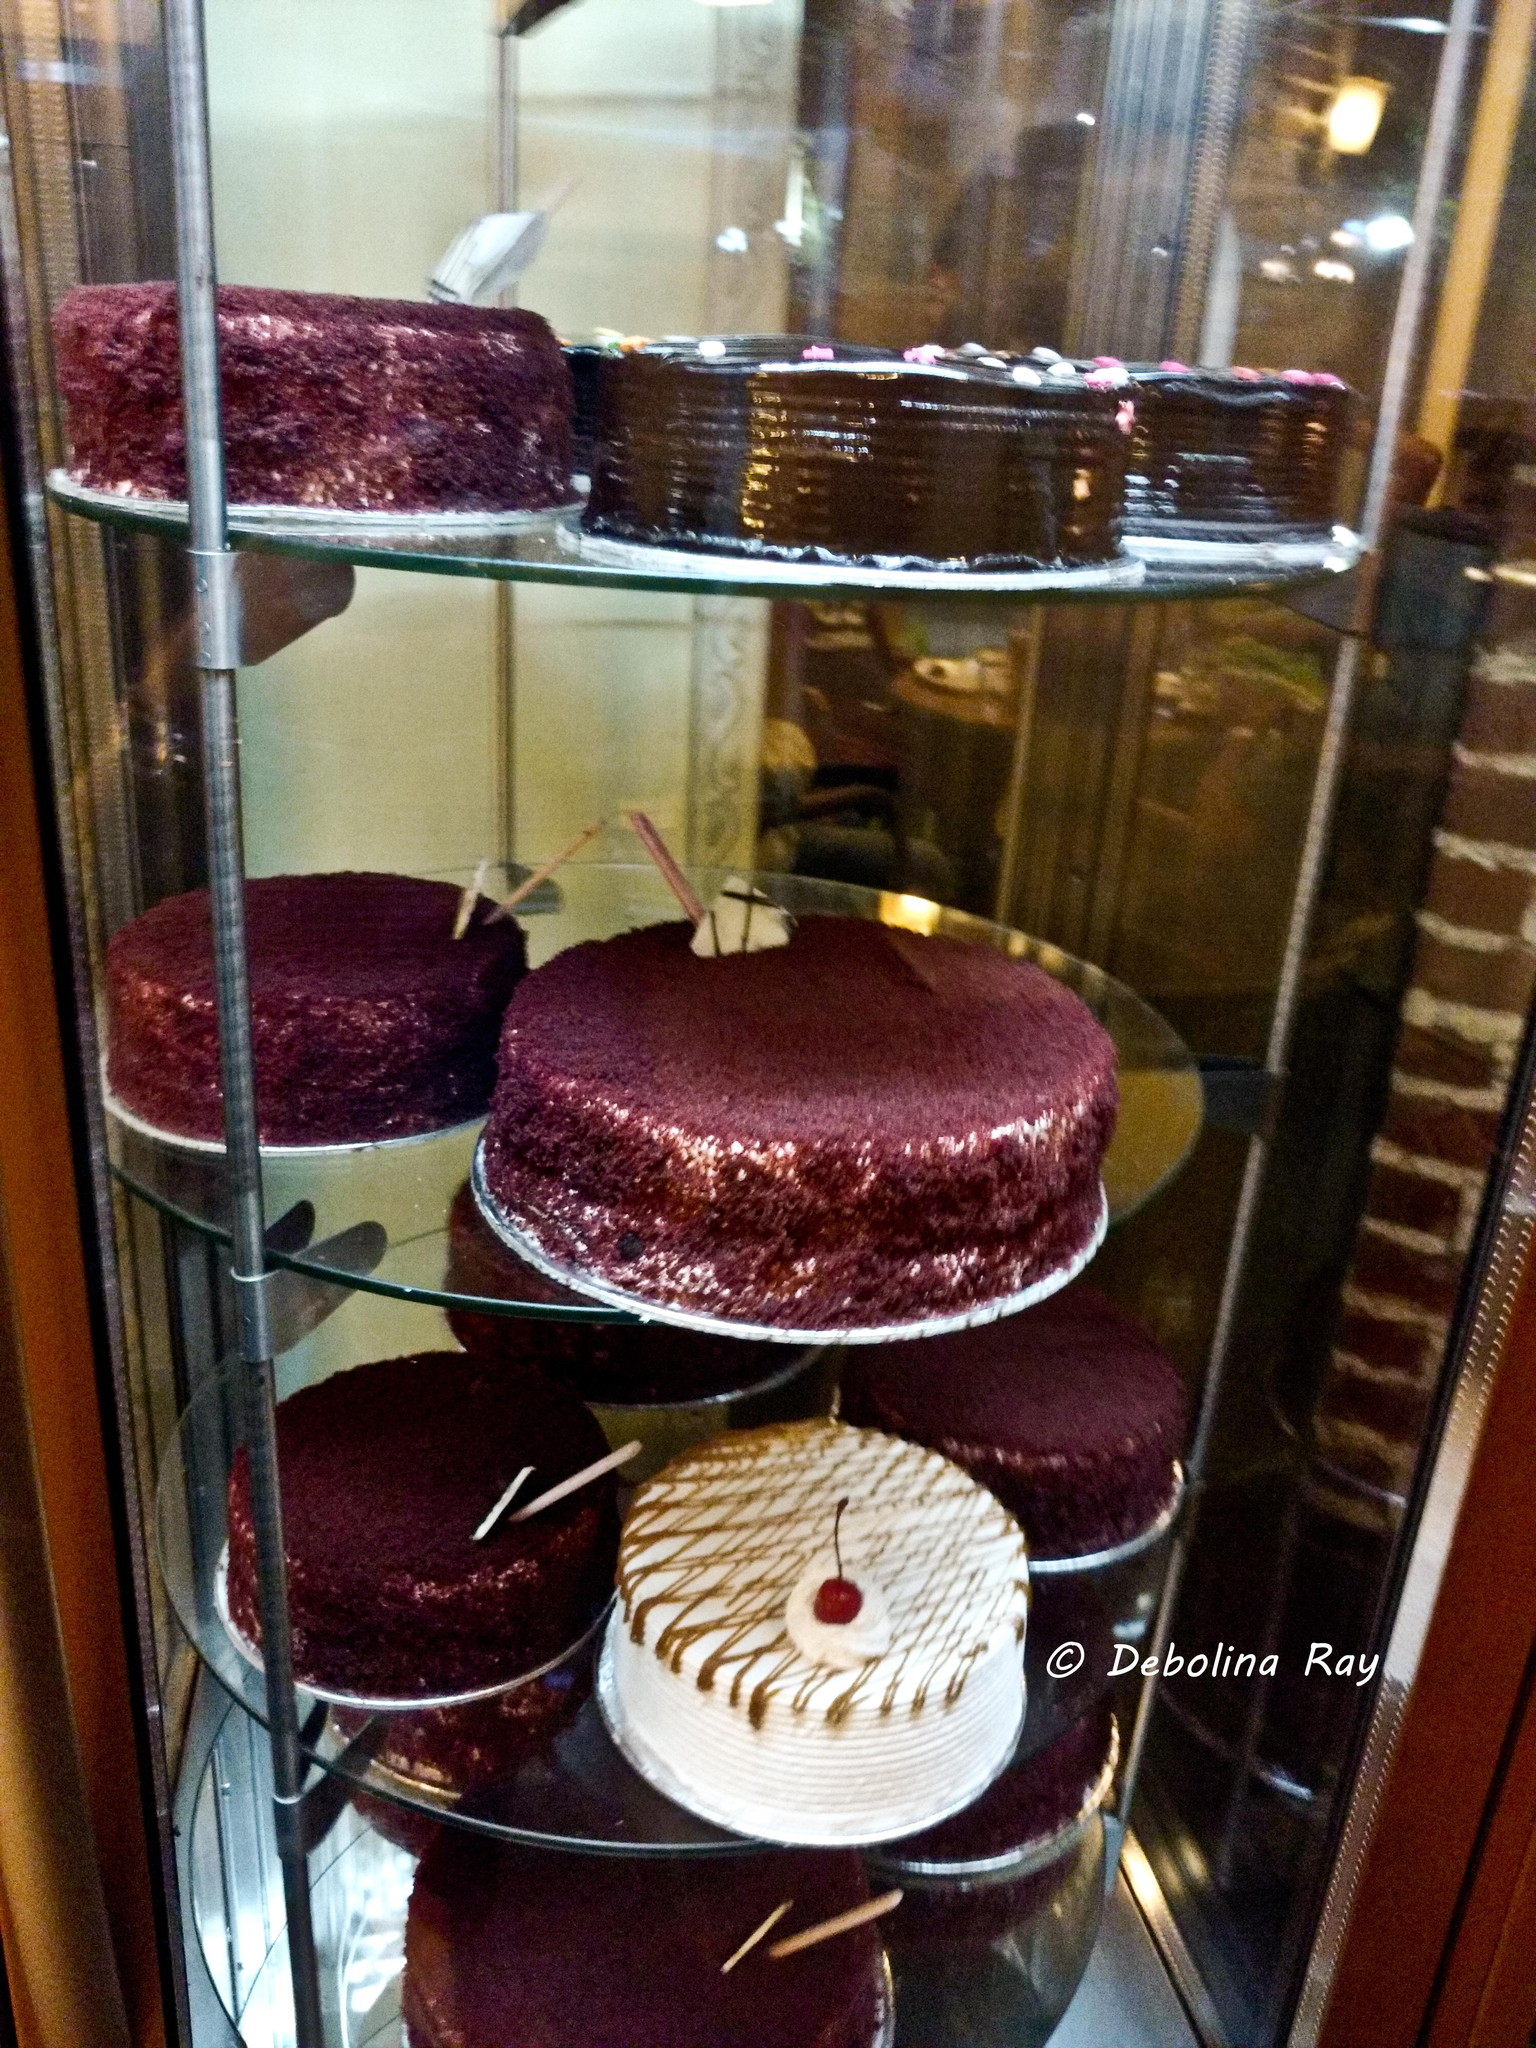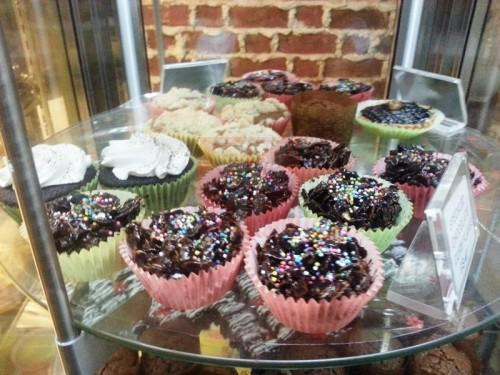The first image is the image on the left, the second image is the image on the right. For the images displayed, is the sentence "A glass case holds at least two whole, unsliced red velvet cakes." factually correct? Answer yes or no. Yes. The first image is the image on the left, the second image is the image on the right. Considering the images on both sides, is "There is a plate of dessert on top of a wooden round table." valid? Answer yes or no. No. 